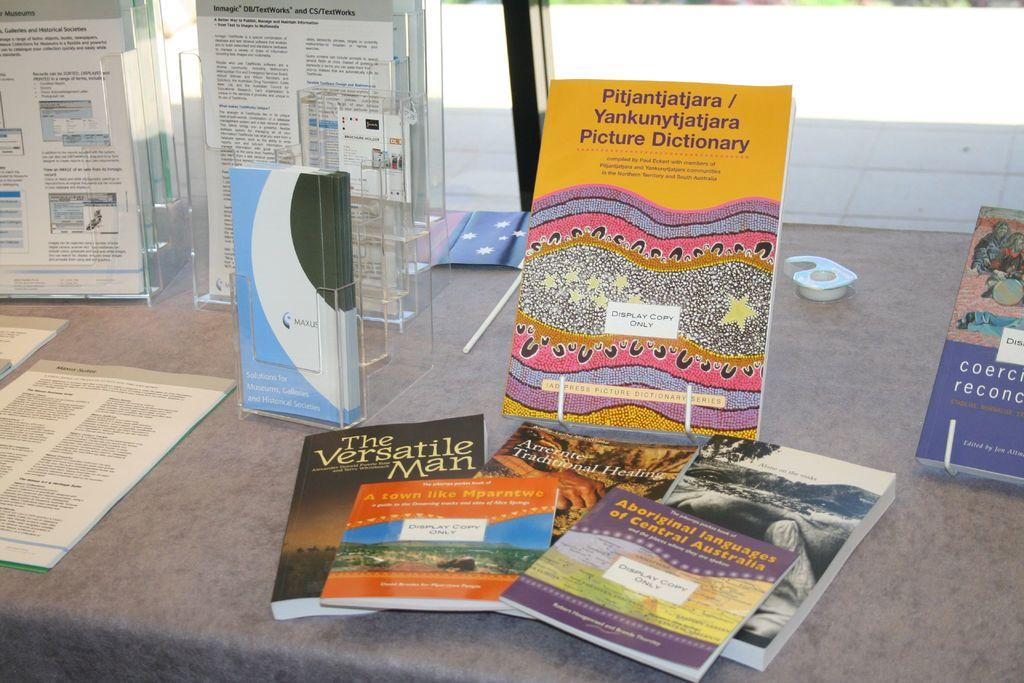<image>
Give a short and clear explanation of the subsequent image. A book titled The Versatile man on a table 